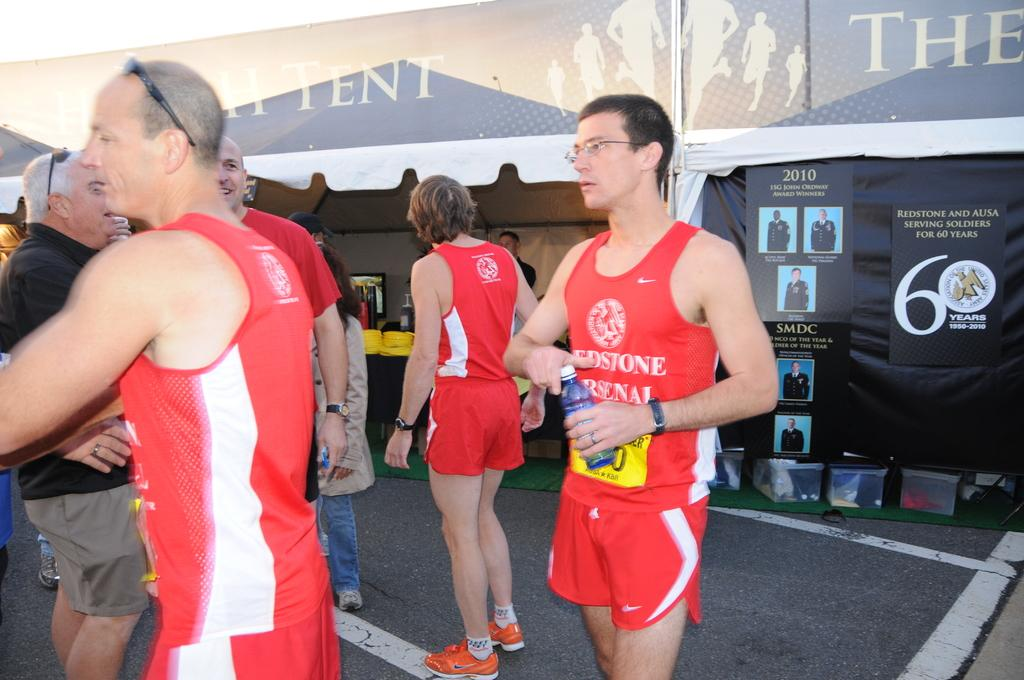<image>
Write a terse but informative summary of the picture. The year 2010 can be seen on a wall behind people in red uniforms. 